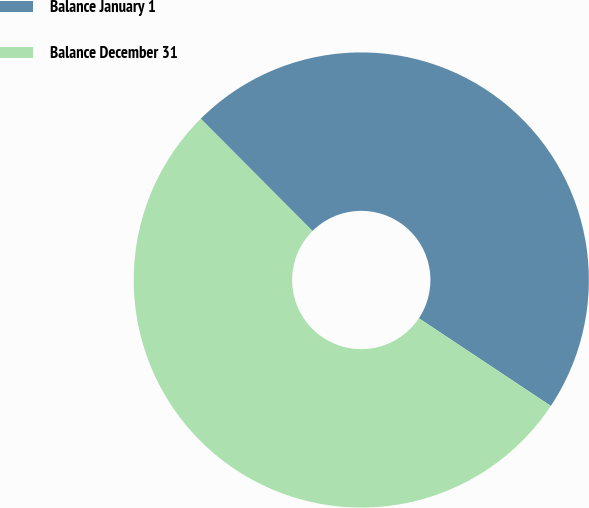<chart> <loc_0><loc_0><loc_500><loc_500><pie_chart><fcel>Balance January 1<fcel>Balance December 31<nl><fcel>46.8%<fcel>53.2%<nl></chart> 